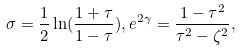<formula> <loc_0><loc_0><loc_500><loc_500>\sigma = \frac { 1 } { 2 } \ln ( \frac { 1 + \tau } { 1 - \tau } ) , e ^ { 2 \gamma } = \frac { 1 - \tau ^ { 2 } } { \tau ^ { 2 } - \zeta ^ { 2 } } ,</formula> 